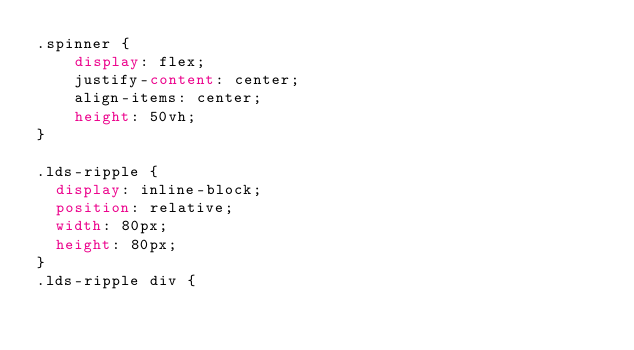<code> <loc_0><loc_0><loc_500><loc_500><_CSS_>.spinner {
    display: flex;
    justify-content: center;
    align-items: center;
    height: 50vh;
}

.lds-ripple {
  display: inline-block;
  position: relative;
  width: 80px;
  height: 80px;
}
.lds-ripple div {</code> 